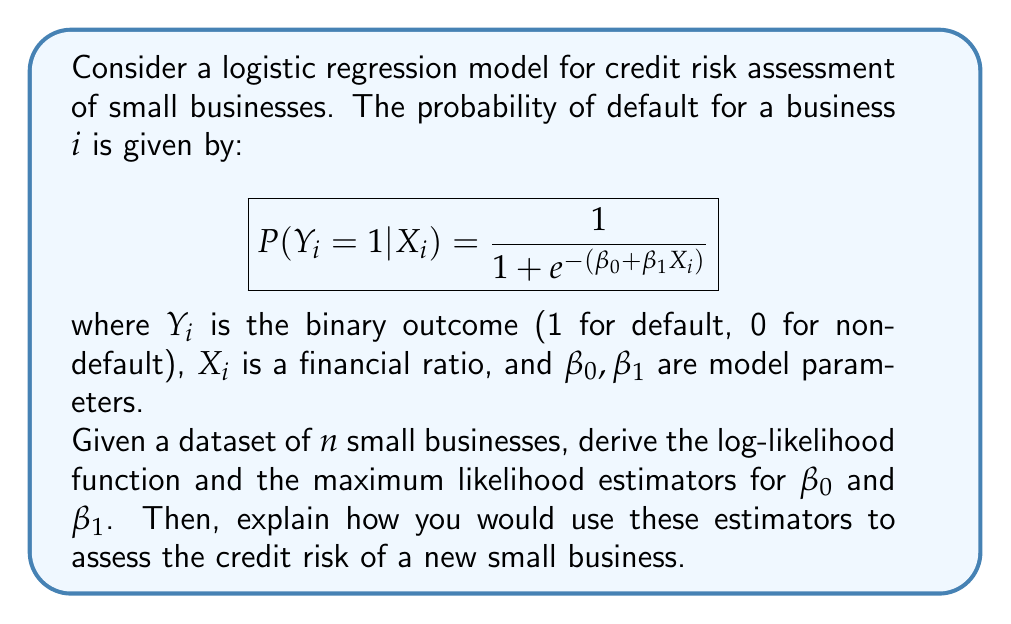Solve this math problem. To solve this problem, we'll follow these steps:

1. Derive the likelihood function
2. Take the natural logarithm to get the log-likelihood function
3. Find the partial derivatives of the log-likelihood with respect to $\beta_0$ and $\beta_1$
4. Set the partial derivatives to zero and solve for $\beta_0$ and $\beta_1$

Step 1: Likelihood function

Let $p_i = P(Y_i = 1|X_i)$. The likelihood function is:

$$L(\beta_0, \beta_1) = \prod_{i=1}^n p_i^{y_i} (1-p_i)^{1-y_i}$$

Step 2: Log-likelihood function

Taking the natural logarithm:

$$\ell(\beta_0, \beta_1) = \sum_{i=1}^n [y_i \ln(p_i) + (1-y_i) \ln(1-p_i)]$$

Substituting $p_i = \frac{1}{1 + e^{-(\beta_0 + \beta_1X_i)}}$:

$$\ell(\beta_0, \beta_1) = \sum_{i=1}^n [y_i (\beta_0 + \beta_1X_i) - \ln(1 + e^{\beta_0 + \beta_1X_i})]$$

Step 3: Partial derivatives

$$\frac{\partial \ell}{\partial \beta_0} = \sum_{i=1}^n [y_i - \frac{e^{\beta_0 + \beta_1X_i}}{1 + e^{\beta_0 + \beta_1X_i}}]$$

$$\frac{\partial \ell}{\partial \beta_1} = \sum_{i=1}^n [y_iX_i - \frac{X_i e^{\beta_0 + \beta_1X_i}}{1 + e^{\beta_0 + \beta_1X_i}}]$$

Step 4: Maximum likelihood estimators

Setting the partial derivatives to zero:

$$\sum_{i=1}^n [y_i - \frac{e^{\beta_0 + \beta_1X_i}}{1 + e^{\beta_0 + \beta_1X_i}}] = 0$$

$$\sum_{i=1}^n [y_iX_i - \frac{X_i e^{\beta_0 + \beta_1X_i}}{1 + e^{\beta_0 + \beta_1X_i}}] = 0$$

These equations don't have closed-form solutions, so we need to use numerical methods like Newton-Raphson or gradient descent to find the maximum likelihood estimators $\hat{\beta_0}$ and $\hat{\beta_1}$.

To assess the credit risk of a new small business:

1. Calculate the financial ratio $X_{new}$ for the new business.
2. Use the estimated coefficients $\hat{\beta_0}$ and $\hat{\beta_1}$ to compute the probability of default:

   $$P(Y_{new} = 1|X_{new}) = \frac{1}{1 + e^{-(\hat{\beta_0} + \hat{\beta_1}X_{new})}}$$

3. Compare this probability to a predetermined threshold to classify the business as high or low risk.
Answer: The maximum likelihood estimators $\hat{\beta_0}$ and $\hat{\beta_1}$ for the logistic regression model are the solutions to the equations:

$$\sum_{i=1}^n [y_i - \frac{e^{\hat{\beta_0} + \hat{\beta_1}X_i}}{1 + e^{\hat{\beta_0} + \hat{\beta_1}X_i}}] = 0$$

$$\sum_{i=1}^n [y_iX_i - \frac{X_i e^{\hat{\beta_0} + \hat{\beta_1}X_i}}{1 + e^{\hat{\beta_0} + \hat{\beta_1}X_i}}] = 0$$

These equations must be solved numerically using methods like Newton-Raphson or gradient descent. 